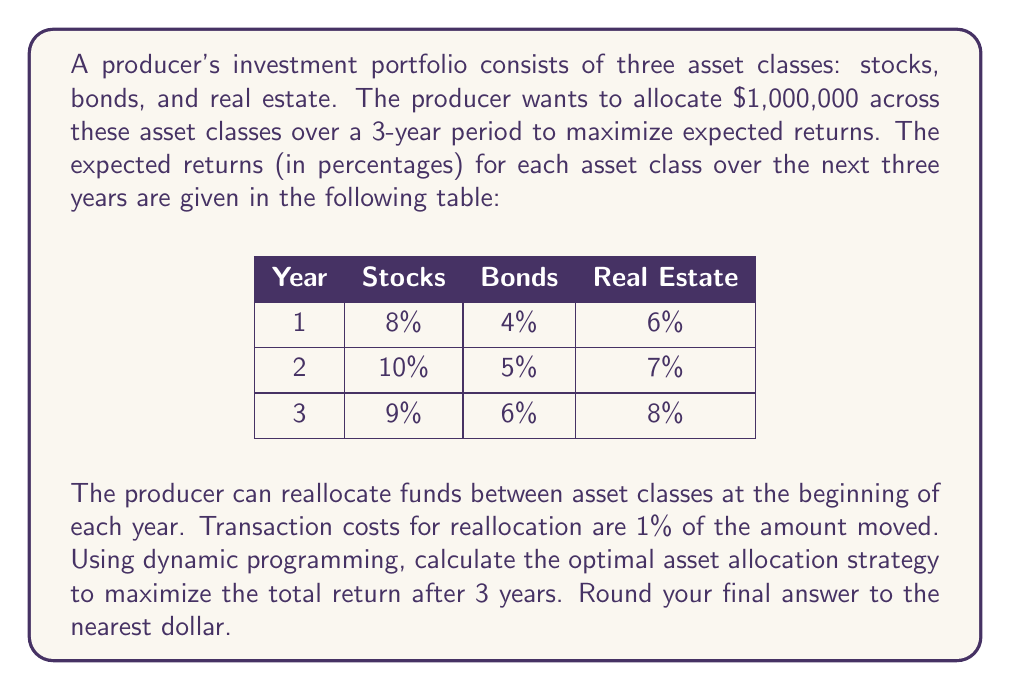Can you answer this question? To solve this problem using dynamic programming, we'll work backwards from the final year to the first year. Let's define our state as $(y, s, b, r)$, where $y$ is the year, and $s$, $b$, and $r$ are the amounts in stocks, bonds, and real estate, respectively.

Let $V(y, s, b, r)$ be the maximum value that can be achieved from year $y$ to the end, starting with allocation $(s, b, r)$.

Step 1: Initialize the final year (year 3)
$$V(3, s, b, r) = 1.09s + 1.06b + 1.08r$$

Step 2: Solve for year 2
For each possible allocation $(s, b, r)$ at the start of year 2, we need to find the best reallocation for year 3. Let $(s', b', r')$ be the new allocation.

$$V(2, s, b, r) = \max_{s',b',r'} \{1.10s + 1.05b + 1.07r - 0.01(|s'-1.10s| + |b'-1.05b| + |r'-1.07r|) + V(3, s', b', r')\}$$

subject to $s' + b' + r' = 1.10s + 1.05b + 1.07r$

Step 3: Solve for year 1
Similarly, for year 1:

$$V(1, s, b, r) = \max_{s',b',r'} \{1.08s + 1.04b + 1.06r - 0.01(|s'-1.08s| + |b'-1.04b| + |r'-1.06r|) + V(2, s', b', r')\}$$

subject to $s' + b' + r' = 1.08s + 1.04b + 1.06r$

Step 4: Solve the initial allocation
Finally, we need to find the best initial allocation:

$$\max_{s,b,r} V(1, s, b, r)$$

subject to $s + b + r = 1,000,000$

To solve this numerically, we would discretize the possible allocations and use a computer to calculate all possible combinations. However, for this problem, we can deduce that the optimal strategy will likely involve allocating most or all of the funds to stocks in the first two years (as they have the highest returns) and then potentially reallocating some funds to real estate in the final year.

Applying this strategy:

Year 1: Allocate all $1,000,000 to stocks
End of Year 1: $1,000,000 * 1.08 = $1,080,000

Year 2: Keep all in stocks
End of Year 2: $1,080,000 * 1.10 = $1,188,000

Year 3: Reallocate to 50% stocks, 50% real estate
Transaction cost: $1,188,000 * 0.5 * 0.01 = $5,940
Beginning of Year 3: $1,188,000 - $5,940 = $1,182,060
End of Year 3: ($1,182,060 * 0.5 * 1.09) + ($1,182,060 * 0.5 * 1.08) = $1,289,445.40
Answer: The optimal asset allocation strategy yields a total return of $1,289,445 after 3 years. 